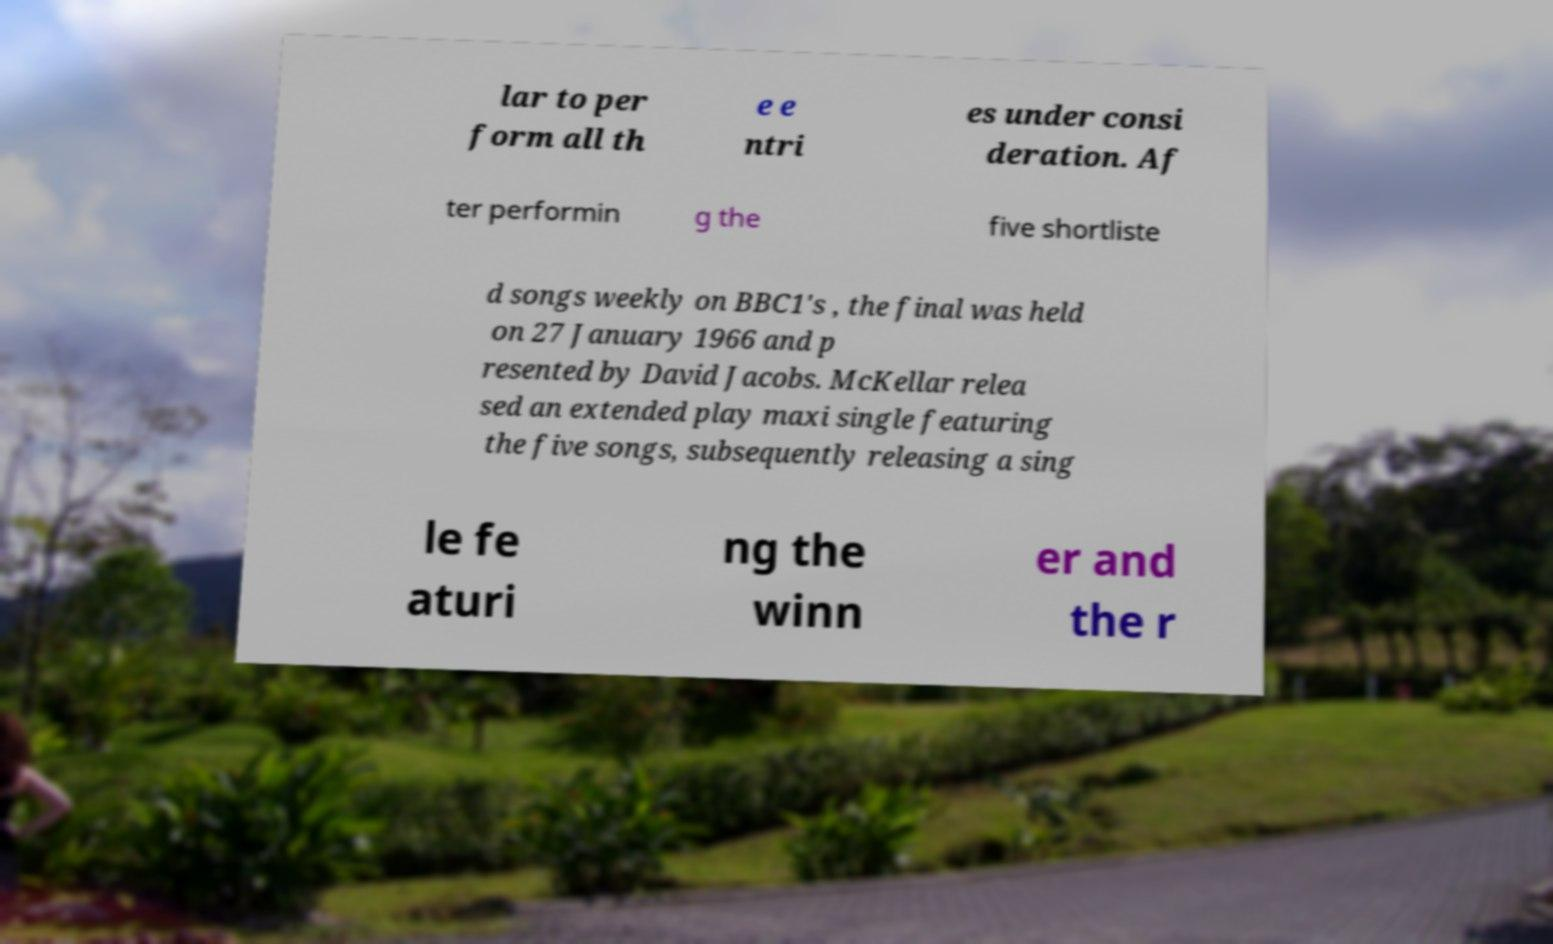Can you read and provide the text displayed in the image?This photo seems to have some interesting text. Can you extract and type it out for me? lar to per form all th e e ntri es under consi deration. Af ter performin g the five shortliste d songs weekly on BBC1's , the final was held on 27 January 1966 and p resented by David Jacobs. McKellar relea sed an extended play maxi single featuring the five songs, subsequently releasing a sing le fe aturi ng the winn er and the r 